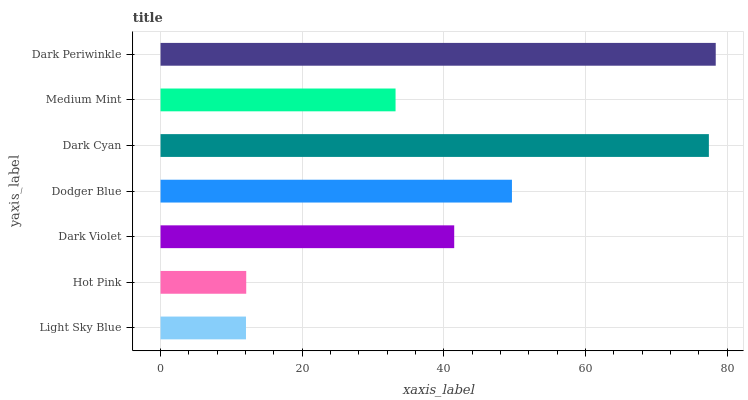Is Light Sky Blue the minimum?
Answer yes or no. Yes. Is Dark Periwinkle the maximum?
Answer yes or no. Yes. Is Hot Pink the minimum?
Answer yes or no. No. Is Hot Pink the maximum?
Answer yes or no. No. Is Hot Pink greater than Light Sky Blue?
Answer yes or no. Yes. Is Light Sky Blue less than Hot Pink?
Answer yes or no. Yes. Is Light Sky Blue greater than Hot Pink?
Answer yes or no. No. Is Hot Pink less than Light Sky Blue?
Answer yes or no. No. Is Dark Violet the high median?
Answer yes or no. Yes. Is Dark Violet the low median?
Answer yes or no. Yes. Is Dodger Blue the high median?
Answer yes or no. No. Is Light Sky Blue the low median?
Answer yes or no. No. 